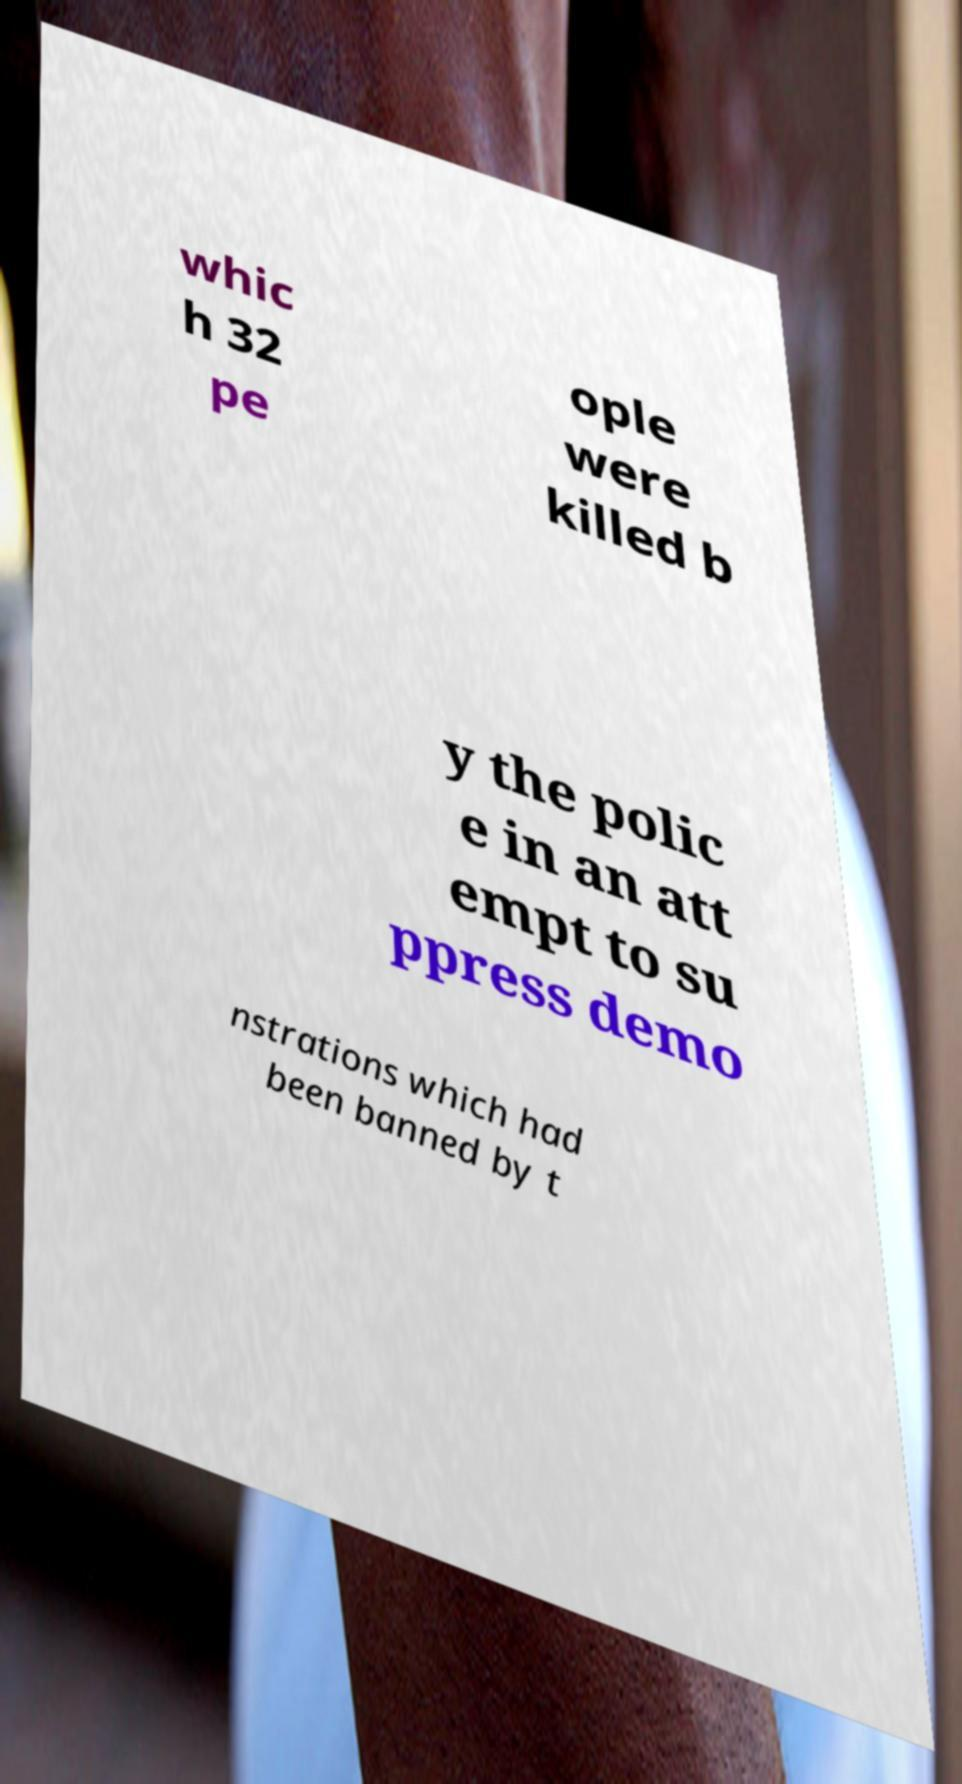There's text embedded in this image that I need extracted. Can you transcribe it verbatim? whic h 32 pe ople were killed b y the polic e in an att empt to su ppress demo nstrations which had been banned by t 